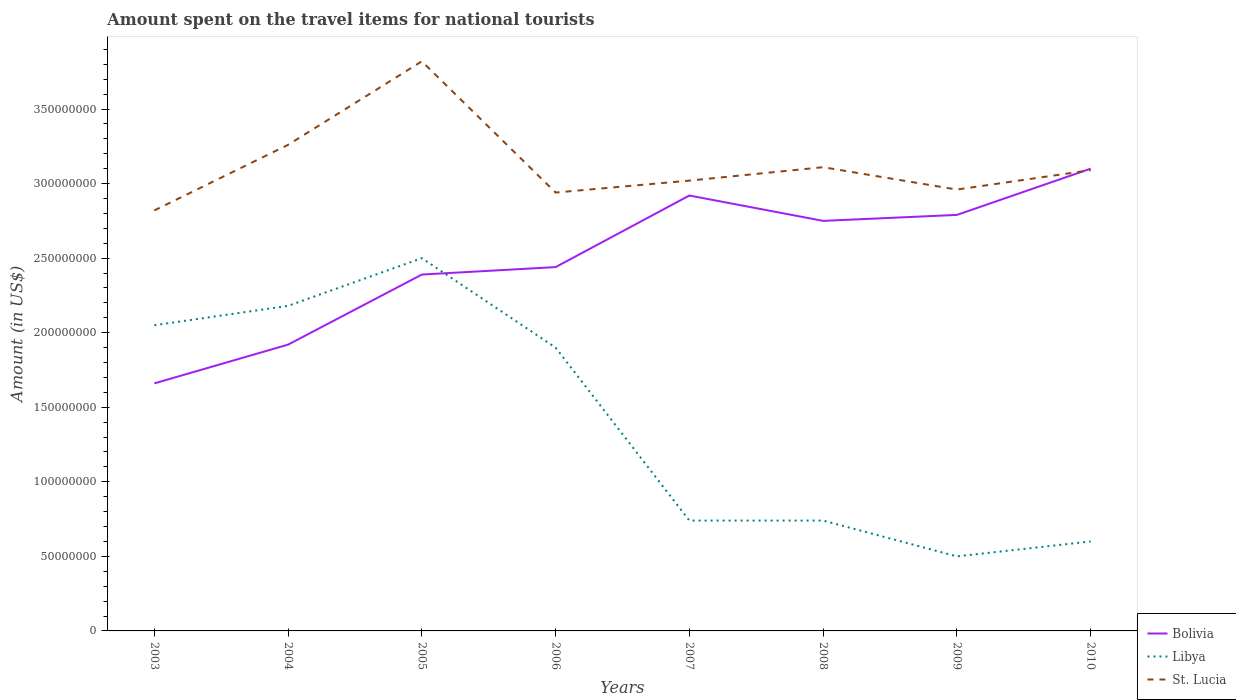Across all years, what is the maximum amount spent on the travel items for national tourists in St. Lucia?
Your response must be concise. 2.82e+08. In which year was the amount spent on the travel items for national tourists in Libya maximum?
Ensure brevity in your answer.  2009. What is the total amount spent on the travel items for national tourists in Bolivia in the graph?
Offer a terse response. -4.80e+07. What is the difference between the highest and the second highest amount spent on the travel items for national tourists in Bolivia?
Offer a very short reply. 1.44e+08. What is the difference between the highest and the lowest amount spent on the travel items for national tourists in Libya?
Ensure brevity in your answer.  4. Is the amount spent on the travel items for national tourists in St. Lucia strictly greater than the amount spent on the travel items for national tourists in Bolivia over the years?
Your response must be concise. No. Are the values on the major ticks of Y-axis written in scientific E-notation?
Your answer should be compact. No. What is the title of the graph?
Keep it short and to the point. Amount spent on the travel items for national tourists. What is the label or title of the X-axis?
Your answer should be very brief. Years. What is the Amount (in US$) of Bolivia in 2003?
Give a very brief answer. 1.66e+08. What is the Amount (in US$) in Libya in 2003?
Ensure brevity in your answer.  2.05e+08. What is the Amount (in US$) of St. Lucia in 2003?
Keep it short and to the point. 2.82e+08. What is the Amount (in US$) in Bolivia in 2004?
Your response must be concise. 1.92e+08. What is the Amount (in US$) in Libya in 2004?
Provide a short and direct response. 2.18e+08. What is the Amount (in US$) of St. Lucia in 2004?
Keep it short and to the point. 3.26e+08. What is the Amount (in US$) of Bolivia in 2005?
Your answer should be compact. 2.39e+08. What is the Amount (in US$) of Libya in 2005?
Your answer should be compact. 2.50e+08. What is the Amount (in US$) of St. Lucia in 2005?
Keep it short and to the point. 3.82e+08. What is the Amount (in US$) of Bolivia in 2006?
Your answer should be compact. 2.44e+08. What is the Amount (in US$) of Libya in 2006?
Offer a terse response. 1.90e+08. What is the Amount (in US$) of St. Lucia in 2006?
Your answer should be very brief. 2.94e+08. What is the Amount (in US$) in Bolivia in 2007?
Give a very brief answer. 2.92e+08. What is the Amount (in US$) of Libya in 2007?
Provide a succinct answer. 7.40e+07. What is the Amount (in US$) of St. Lucia in 2007?
Provide a succinct answer. 3.02e+08. What is the Amount (in US$) of Bolivia in 2008?
Offer a terse response. 2.75e+08. What is the Amount (in US$) in Libya in 2008?
Your response must be concise. 7.40e+07. What is the Amount (in US$) of St. Lucia in 2008?
Make the answer very short. 3.11e+08. What is the Amount (in US$) in Bolivia in 2009?
Give a very brief answer. 2.79e+08. What is the Amount (in US$) of Libya in 2009?
Your answer should be compact. 5.00e+07. What is the Amount (in US$) of St. Lucia in 2009?
Provide a succinct answer. 2.96e+08. What is the Amount (in US$) of Bolivia in 2010?
Provide a succinct answer. 3.10e+08. What is the Amount (in US$) in Libya in 2010?
Keep it short and to the point. 6.00e+07. What is the Amount (in US$) of St. Lucia in 2010?
Provide a short and direct response. 3.09e+08. Across all years, what is the maximum Amount (in US$) of Bolivia?
Provide a short and direct response. 3.10e+08. Across all years, what is the maximum Amount (in US$) in Libya?
Make the answer very short. 2.50e+08. Across all years, what is the maximum Amount (in US$) of St. Lucia?
Make the answer very short. 3.82e+08. Across all years, what is the minimum Amount (in US$) in Bolivia?
Make the answer very short. 1.66e+08. Across all years, what is the minimum Amount (in US$) in St. Lucia?
Offer a very short reply. 2.82e+08. What is the total Amount (in US$) of Bolivia in the graph?
Ensure brevity in your answer.  2.00e+09. What is the total Amount (in US$) of Libya in the graph?
Provide a succinct answer. 1.12e+09. What is the total Amount (in US$) in St. Lucia in the graph?
Give a very brief answer. 2.50e+09. What is the difference between the Amount (in US$) in Bolivia in 2003 and that in 2004?
Your response must be concise. -2.60e+07. What is the difference between the Amount (in US$) in Libya in 2003 and that in 2004?
Make the answer very short. -1.30e+07. What is the difference between the Amount (in US$) in St. Lucia in 2003 and that in 2004?
Offer a very short reply. -4.40e+07. What is the difference between the Amount (in US$) in Bolivia in 2003 and that in 2005?
Keep it short and to the point. -7.30e+07. What is the difference between the Amount (in US$) in Libya in 2003 and that in 2005?
Ensure brevity in your answer.  -4.50e+07. What is the difference between the Amount (in US$) of St. Lucia in 2003 and that in 2005?
Provide a short and direct response. -1.00e+08. What is the difference between the Amount (in US$) of Bolivia in 2003 and that in 2006?
Make the answer very short. -7.80e+07. What is the difference between the Amount (in US$) of Libya in 2003 and that in 2006?
Keep it short and to the point. 1.50e+07. What is the difference between the Amount (in US$) of St. Lucia in 2003 and that in 2006?
Give a very brief answer. -1.20e+07. What is the difference between the Amount (in US$) of Bolivia in 2003 and that in 2007?
Ensure brevity in your answer.  -1.26e+08. What is the difference between the Amount (in US$) in Libya in 2003 and that in 2007?
Provide a short and direct response. 1.31e+08. What is the difference between the Amount (in US$) of St. Lucia in 2003 and that in 2007?
Give a very brief answer. -2.00e+07. What is the difference between the Amount (in US$) in Bolivia in 2003 and that in 2008?
Provide a succinct answer. -1.09e+08. What is the difference between the Amount (in US$) in Libya in 2003 and that in 2008?
Ensure brevity in your answer.  1.31e+08. What is the difference between the Amount (in US$) of St. Lucia in 2003 and that in 2008?
Your answer should be compact. -2.90e+07. What is the difference between the Amount (in US$) of Bolivia in 2003 and that in 2009?
Your response must be concise. -1.13e+08. What is the difference between the Amount (in US$) of Libya in 2003 and that in 2009?
Offer a terse response. 1.55e+08. What is the difference between the Amount (in US$) of St. Lucia in 2003 and that in 2009?
Your answer should be very brief. -1.40e+07. What is the difference between the Amount (in US$) of Bolivia in 2003 and that in 2010?
Offer a terse response. -1.44e+08. What is the difference between the Amount (in US$) of Libya in 2003 and that in 2010?
Ensure brevity in your answer.  1.45e+08. What is the difference between the Amount (in US$) in St. Lucia in 2003 and that in 2010?
Your response must be concise. -2.70e+07. What is the difference between the Amount (in US$) in Bolivia in 2004 and that in 2005?
Provide a short and direct response. -4.70e+07. What is the difference between the Amount (in US$) of Libya in 2004 and that in 2005?
Your answer should be compact. -3.20e+07. What is the difference between the Amount (in US$) of St. Lucia in 2004 and that in 2005?
Your response must be concise. -5.60e+07. What is the difference between the Amount (in US$) of Bolivia in 2004 and that in 2006?
Your answer should be very brief. -5.20e+07. What is the difference between the Amount (in US$) of Libya in 2004 and that in 2006?
Your answer should be compact. 2.80e+07. What is the difference between the Amount (in US$) in St. Lucia in 2004 and that in 2006?
Keep it short and to the point. 3.20e+07. What is the difference between the Amount (in US$) of Bolivia in 2004 and that in 2007?
Make the answer very short. -1.00e+08. What is the difference between the Amount (in US$) in Libya in 2004 and that in 2007?
Ensure brevity in your answer.  1.44e+08. What is the difference between the Amount (in US$) in St. Lucia in 2004 and that in 2007?
Give a very brief answer. 2.40e+07. What is the difference between the Amount (in US$) of Bolivia in 2004 and that in 2008?
Offer a very short reply. -8.30e+07. What is the difference between the Amount (in US$) of Libya in 2004 and that in 2008?
Give a very brief answer. 1.44e+08. What is the difference between the Amount (in US$) of St. Lucia in 2004 and that in 2008?
Your answer should be very brief. 1.50e+07. What is the difference between the Amount (in US$) in Bolivia in 2004 and that in 2009?
Make the answer very short. -8.70e+07. What is the difference between the Amount (in US$) in Libya in 2004 and that in 2009?
Your answer should be very brief. 1.68e+08. What is the difference between the Amount (in US$) in St. Lucia in 2004 and that in 2009?
Provide a succinct answer. 3.00e+07. What is the difference between the Amount (in US$) in Bolivia in 2004 and that in 2010?
Give a very brief answer. -1.18e+08. What is the difference between the Amount (in US$) in Libya in 2004 and that in 2010?
Offer a very short reply. 1.58e+08. What is the difference between the Amount (in US$) in St. Lucia in 2004 and that in 2010?
Make the answer very short. 1.70e+07. What is the difference between the Amount (in US$) of Bolivia in 2005 and that in 2006?
Your answer should be compact. -5.00e+06. What is the difference between the Amount (in US$) of Libya in 2005 and that in 2006?
Make the answer very short. 6.00e+07. What is the difference between the Amount (in US$) in St. Lucia in 2005 and that in 2006?
Provide a succinct answer. 8.80e+07. What is the difference between the Amount (in US$) in Bolivia in 2005 and that in 2007?
Your response must be concise. -5.30e+07. What is the difference between the Amount (in US$) in Libya in 2005 and that in 2007?
Give a very brief answer. 1.76e+08. What is the difference between the Amount (in US$) in St. Lucia in 2005 and that in 2007?
Make the answer very short. 8.00e+07. What is the difference between the Amount (in US$) in Bolivia in 2005 and that in 2008?
Provide a succinct answer. -3.60e+07. What is the difference between the Amount (in US$) of Libya in 2005 and that in 2008?
Your answer should be very brief. 1.76e+08. What is the difference between the Amount (in US$) of St. Lucia in 2005 and that in 2008?
Provide a succinct answer. 7.10e+07. What is the difference between the Amount (in US$) of Bolivia in 2005 and that in 2009?
Give a very brief answer. -4.00e+07. What is the difference between the Amount (in US$) in Libya in 2005 and that in 2009?
Offer a very short reply. 2.00e+08. What is the difference between the Amount (in US$) of St. Lucia in 2005 and that in 2009?
Your response must be concise. 8.60e+07. What is the difference between the Amount (in US$) in Bolivia in 2005 and that in 2010?
Your answer should be very brief. -7.10e+07. What is the difference between the Amount (in US$) in Libya in 2005 and that in 2010?
Keep it short and to the point. 1.90e+08. What is the difference between the Amount (in US$) of St. Lucia in 2005 and that in 2010?
Provide a succinct answer. 7.30e+07. What is the difference between the Amount (in US$) in Bolivia in 2006 and that in 2007?
Your response must be concise. -4.80e+07. What is the difference between the Amount (in US$) of Libya in 2006 and that in 2007?
Make the answer very short. 1.16e+08. What is the difference between the Amount (in US$) of St. Lucia in 2006 and that in 2007?
Provide a short and direct response. -8.00e+06. What is the difference between the Amount (in US$) in Bolivia in 2006 and that in 2008?
Your response must be concise. -3.10e+07. What is the difference between the Amount (in US$) in Libya in 2006 and that in 2008?
Provide a short and direct response. 1.16e+08. What is the difference between the Amount (in US$) in St. Lucia in 2006 and that in 2008?
Offer a terse response. -1.70e+07. What is the difference between the Amount (in US$) of Bolivia in 2006 and that in 2009?
Offer a terse response. -3.50e+07. What is the difference between the Amount (in US$) of Libya in 2006 and that in 2009?
Ensure brevity in your answer.  1.40e+08. What is the difference between the Amount (in US$) of St. Lucia in 2006 and that in 2009?
Your response must be concise. -2.00e+06. What is the difference between the Amount (in US$) of Bolivia in 2006 and that in 2010?
Give a very brief answer. -6.60e+07. What is the difference between the Amount (in US$) of Libya in 2006 and that in 2010?
Provide a short and direct response. 1.30e+08. What is the difference between the Amount (in US$) of St. Lucia in 2006 and that in 2010?
Offer a terse response. -1.50e+07. What is the difference between the Amount (in US$) in Bolivia in 2007 and that in 2008?
Provide a succinct answer. 1.70e+07. What is the difference between the Amount (in US$) in Libya in 2007 and that in 2008?
Provide a succinct answer. 0. What is the difference between the Amount (in US$) in St. Lucia in 2007 and that in 2008?
Keep it short and to the point. -9.00e+06. What is the difference between the Amount (in US$) of Bolivia in 2007 and that in 2009?
Make the answer very short. 1.30e+07. What is the difference between the Amount (in US$) in Libya in 2007 and that in 2009?
Keep it short and to the point. 2.40e+07. What is the difference between the Amount (in US$) of Bolivia in 2007 and that in 2010?
Provide a short and direct response. -1.80e+07. What is the difference between the Amount (in US$) of Libya in 2007 and that in 2010?
Give a very brief answer. 1.40e+07. What is the difference between the Amount (in US$) of St. Lucia in 2007 and that in 2010?
Offer a terse response. -7.00e+06. What is the difference between the Amount (in US$) of Bolivia in 2008 and that in 2009?
Your response must be concise. -4.00e+06. What is the difference between the Amount (in US$) in Libya in 2008 and that in 2009?
Offer a very short reply. 2.40e+07. What is the difference between the Amount (in US$) in St. Lucia in 2008 and that in 2009?
Offer a very short reply. 1.50e+07. What is the difference between the Amount (in US$) of Bolivia in 2008 and that in 2010?
Offer a very short reply. -3.50e+07. What is the difference between the Amount (in US$) in Libya in 2008 and that in 2010?
Keep it short and to the point. 1.40e+07. What is the difference between the Amount (in US$) in St. Lucia in 2008 and that in 2010?
Your answer should be compact. 2.00e+06. What is the difference between the Amount (in US$) of Bolivia in 2009 and that in 2010?
Provide a short and direct response. -3.10e+07. What is the difference between the Amount (in US$) in Libya in 2009 and that in 2010?
Give a very brief answer. -1.00e+07. What is the difference between the Amount (in US$) of St. Lucia in 2009 and that in 2010?
Your answer should be compact. -1.30e+07. What is the difference between the Amount (in US$) in Bolivia in 2003 and the Amount (in US$) in Libya in 2004?
Provide a succinct answer. -5.20e+07. What is the difference between the Amount (in US$) of Bolivia in 2003 and the Amount (in US$) of St. Lucia in 2004?
Provide a short and direct response. -1.60e+08. What is the difference between the Amount (in US$) in Libya in 2003 and the Amount (in US$) in St. Lucia in 2004?
Your response must be concise. -1.21e+08. What is the difference between the Amount (in US$) in Bolivia in 2003 and the Amount (in US$) in Libya in 2005?
Keep it short and to the point. -8.40e+07. What is the difference between the Amount (in US$) in Bolivia in 2003 and the Amount (in US$) in St. Lucia in 2005?
Provide a succinct answer. -2.16e+08. What is the difference between the Amount (in US$) of Libya in 2003 and the Amount (in US$) of St. Lucia in 2005?
Your answer should be very brief. -1.77e+08. What is the difference between the Amount (in US$) in Bolivia in 2003 and the Amount (in US$) in Libya in 2006?
Offer a very short reply. -2.40e+07. What is the difference between the Amount (in US$) of Bolivia in 2003 and the Amount (in US$) of St. Lucia in 2006?
Offer a very short reply. -1.28e+08. What is the difference between the Amount (in US$) in Libya in 2003 and the Amount (in US$) in St. Lucia in 2006?
Your answer should be very brief. -8.90e+07. What is the difference between the Amount (in US$) of Bolivia in 2003 and the Amount (in US$) of Libya in 2007?
Provide a short and direct response. 9.20e+07. What is the difference between the Amount (in US$) in Bolivia in 2003 and the Amount (in US$) in St. Lucia in 2007?
Give a very brief answer. -1.36e+08. What is the difference between the Amount (in US$) in Libya in 2003 and the Amount (in US$) in St. Lucia in 2007?
Offer a terse response. -9.70e+07. What is the difference between the Amount (in US$) of Bolivia in 2003 and the Amount (in US$) of Libya in 2008?
Keep it short and to the point. 9.20e+07. What is the difference between the Amount (in US$) in Bolivia in 2003 and the Amount (in US$) in St. Lucia in 2008?
Provide a succinct answer. -1.45e+08. What is the difference between the Amount (in US$) of Libya in 2003 and the Amount (in US$) of St. Lucia in 2008?
Your answer should be compact. -1.06e+08. What is the difference between the Amount (in US$) of Bolivia in 2003 and the Amount (in US$) of Libya in 2009?
Your answer should be very brief. 1.16e+08. What is the difference between the Amount (in US$) in Bolivia in 2003 and the Amount (in US$) in St. Lucia in 2009?
Your response must be concise. -1.30e+08. What is the difference between the Amount (in US$) of Libya in 2003 and the Amount (in US$) of St. Lucia in 2009?
Give a very brief answer. -9.10e+07. What is the difference between the Amount (in US$) of Bolivia in 2003 and the Amount (in US$) of Libya in 2010?
Offer a terse response. 1.06e+08. What is the difference between the Amount (in US$) of Bolivia in 2003 and the Amount (in US$) of St. Lucia in 2010?
Provide a short and direct response. -1.43e+08. What is the difference between the Amount (in US$) of Libya in 2003 and the Amount (in US$) of St. Lucia in 2010?
Your answer should be compact. -1.04e+08. What is the difference between the Amount (in US$) in Bolivia in 2004 and the Amount (in US$) in Libya in 2005?
Make the answer very short. -5.80e+07. What is the difference between the Amount (in US$) in Bolivia in 2004 and the Amount (in US$) in St. Lucia in 2005?
Provide a short and direct response. -1.90e+08. What is the difference between the Amount (in US$) in Libya in 2004 and the Amount (in US$) in St. Lucia in 2005?
Provide a short and direct response. -1.64e+08. What is the difference between the Amount (in US$) in Bolivia in 2004 and the Amount (in US$) in St. Lucia in 2006?
Give a very brief answer. -1.02e+08. What is the difference between the Amount (in US$) of Libya in 2004 and the Amount (in US$) of St. Lucia in 2006?
Give a very brief answer. -7.60e+07. What is the difference between the Amount (in US$) of Bolivia in 2004 and the Amount (in US$) of Libya in 2007?
Keep it short and to the point. 1.18e+08. What is the difference between the Amount (in US$) of Bolivia in 2004 and the Amount (in US$) of St. Lucia in 2007?
Your answer should be compact. -1.10e+08. What is the difference between the Amount (in US$) of Libya in 2004 and the Amount (in US$) of St. Lucia in 2007?
Give a very brief answer. -8.40e+07. What is the difference between the Amount (in US$) in Bolivia in 2004 and the Amount (in US$) in Libya in 2008?
Give a very brief answer. 1.18e+08. What is the difference between the Amount (in US$) in Bolivia in 2004 and the Amount (in US$) in St. Lucia in 2008?
Your response must be concise. -1.19e+08. What is the difference between the Amount (in US$) of Libya in 2004 and the Amount (in US$) of St. Lucia in 2008?
Offer a terse response. -9.30e+07. What is the difference between the Amount (in US$) in Bolivia in 2004 and the Amount (in US$) in Libya in 2009?
Ensure brevity in your answer.  1.42e+08. What is the difference between the Amount (in US$) of Bolivia in 2004 and the Amount (in US$) of St. Lucia in 2009?
Your answer should be very brief. -1.04e+08. What is the difference between the Amount (in US$) of Libya in 2004 and the Amount (in US$) of St. Lucia in 2009?
Offer a very short reply. -7.80e+07. What is the difference between the Amount (in US$) in Bolivia in 2004 and the Amount (in US$) in Libya in 2010?
Offer a very short reply. 1.32e+08. What is the difference between the Amount (in US$) in Bolivia in 2004 and the Amount (in US$) in St. Lucia in 2010?
Ensure brevity in your answer.  -1.17e+08. What is the difference between the Amount (in US$) of Libya in 2004 and the Amount (in US$) of St. Lucia in 2010?
Your answer should be compact. -9.10e+07. What is the difference between the Amount (in US$) of Bolivia in 2005 and the Amount (in US$) of Libya in 2006?
Provide a short and direct response. 4.90e+07. What is the difference between the Amount (in US$) in Bolivia in 2005 and the Amount (in US$) in St. Lucia in 2006?
Your response must be concise. -5.50e+07. What is the difference between the Amount (in US$) in Libya in 2005 and the Amount (in US$) in St. Lucia in 2006?
Your answer should be very brief. -4.40e+07. What is the difference between the Amount (in US$) of Bolivia in 2005 and the Amount (in US$) of Libya in 2007?
Your answer should be very brief. 1.65e+08. What is the difference between the Amount (in US$) of Bolivia in 2005 and the Amount (in US$) of St. Lucia in 2007?
Provide a short and direct response. -6.30e+07. What is the difference between the Amount (in US$) of Libya in 2005 and the Amount (in US$) of St. Lucia in 2007?
Offer a very short reply. -5.20e+07. What is the difference between the Amount (in US$) of Bolivia in 2005 and the Amount (in US$) of Libya in 2008?
Your answer should be very brief. 1.65e+08. What is the difference between the Amount (in US$) of Bolivia in 2005 and the Amount (in US$) of St. Lucia in 2008?
Ensure brevity in your answer.  -7.20e+07. What is the difference between the Amount (in US$) in Libya in 2005 and the Amount (in US$) in St. Lucia in 2008?
Give a very brief answer. -6.10e+07. What is the difference between the Amount (in US$) of Bolivia in 2005 and the Amount (in US$) of Libya in 2009?
Your answer should be compact. 1.89e+08. What is the difference between the Amount (in US$) in Bolivia in 2005 and the Amount (in US$) in St. Lucia in 2009?
Your answer should be compact. -5.70e+07. What is the difference between the Amount (in US$) of Libya in 2005 and the Amount (in US$) of St. Lucia in 2009?
Give a very brief answer. -4.60e+07. What is the difference between the Amount (in US$) in Bolivia in 2005 and the Amount (in US$) in Libya in 2010?
Give a very brief answer. 1.79e+08. What is the difference between the Amount (in US$) in Bolivia in 2005 and the Amount (in US$) in St. Lucia in 2010?
Your answer should be very brief. -7.00e+07. What is the difference between the Amount (in US$) in Libya in 2005 and the Amount (in US$) in St. Lucia in 2010?
Ensure brevity in your answer.  -5.90e+07. What is the difference between the Amount (in US$) of Bolivia in 2006 and the Amount (in US$) of Libya in 2007?
Your answer should be very brief. 1.70e+08. What is the difference between the Amount (in US$) of Bolivia in 2006 and the Amount (in US$) of St. Lucia in 2007?
Your answer should be very brief. -5.80e+07. What is the difference between the Amount (in US$) of Libya in 2006 and the Amount (in US$) of St. Lucia in 2007?
Offer a very short reply. -1.12e+08. What is the difference between the Amount (in US$) of Bolivia in 2006 and the Amount (in US$) of Libya in 2008?
Make the answer very short. 1.70e+08. What is the difference between the Amount (in US$) of Bolivia in 2006 and the Amount (in US$) of St. Lucia in 2008?
Give a very brief answer. -6.70e+07. What is the difference between the Amount (in US$) in Libya in 2006 and the Amount (in US$) in St. Lucia in 2008?
Keep it short and to the point. -1.21e+08. What is the difference between the Amount (in US$) in Bolivia in 2006 and the Amount (in US$) in Libya in 2009?
Your response must be concise. 1.94e+08. What is the difference between the Amount (in US$) in Bolivia in 2006 and the Amount (in US$) in St. Lucia in 2009?
Offer a very short reply. -5.20e+07. What is the difference between the Amount (in US$) in Libya in 2006 and the Amount (in US$) in St. Lucia in 2009?
Your response must be concise. -1.06e+08. What is the difference between the Amount (in US$) of Bolivia in 2006 and the Amount (in US$) of Libya in 2010?
Your answer should be very brief. 1.84e+08. What is the difference between the Amount (in US$) in Bolivia in 2006 and the Amount (in US$) in St. Lucia in 2010?
Offer a very short reply. -6.50e+07. What is the difference between the Amount (in US$) in Libya in 2006 and the Amount (in US$) in St. Lucia in 2010?
Offer a very short reply. -1.19e+08. What is the difference between the Amount (in US$) of Bolivia in 2007 and the Amount (in US$) of Libya in 2008?
Your answer should be very brief. 2.18e+08. What is the difference between the Amount (in US$) in Bolivia in 2007 and the Amount (in US$) in St. Lucia in 2008?
Provide a short and direct response. -1.90e+07. What is the difference between the Amount (in US$) of Libya in 2007 and the Amount (in US$) of St. Lucia in 2008?
Keep it short and to the point. -2.37e+08. What is the difference between the Amount (in US$) in Bolivia in 2007 and the Amount (in US$) in Libya in 2009?
Make the answer very short. 2.42e+08. What is the difference between the Amount (in US$) of Bolivia in 2007 and the Amount (in US$) of St. Lucia in 2009?
Provide a short and direct response. -4.00e+06. What is the difference between the Amount (in US$) of Libya in 2007 and the Amount (in US$) of St. Lucia in 2009?
Offer a terse response. -2.22e+08. What is the difference between the Amount (in US$) of Bolivia in 2007 and the Amount (in US$) of Libya in 2010?
Your response must be concise. 2.32e+08. What is the difference between the Amount (in US$) in Bolivia in 2007 and the Amount (in US$) in St. Lucia in 2010?
Ensure brevity in your answer.  -1.70e+07. What is the difference between the Amount (in US$) in Libya in 2007 and the Amount (in US$) in St. Lucia in 2010?
Make the answer very short. -2.35e+08. What is the difference between the Amount (in US$) of Bolivia in 2008 and the Amount (in US$) of Libya in 2009?
Make the answer very short. 2.25e+08. What is the difference between the Amount (in US$) in Bolivia in 2008 and the Amount (in US$) in St. Lucia in 2009?
Offer a terse response. -2.10e+07. What is the difference between the Amount (in US$) in Libya in 2008 and the Amount (in US$) in St. Lucia in 2009?
Offer a very short reply. -2.22e+08. What is the difference between the Amount (in US$) in Bolivia in 2008 and the Amount (in US$) in Libya in 2010?
Make the answer very short. 2.15e+08. What is the difference between the Amount (in US$) of Bolivia in 2008 and the Amount (in US$) of St. Lucia in 2010?
Make the answer very short. -3.40e+07. What is the difference between the Amount (in US$) of Libya in 2008 and the Amount (in US$) of St. Lucia in 2010?
Offer a very short reply. -2.35e+08. What is the difference between the Amount (in US$) of Bolivia in 2009 and the Amount (in US$) of Libya in 2010?
Your response must be concise. 2.19e+08. What is the difference between the Amount (in US$) of Bolivia in 2009 and the Amount (in US$) of St. Lucia in 2010?
Keep it short and to the point. -3.00e+07. What is the difference between the Amount (in US$) in Libya in 2009 and the Amount (in US$) in St. Lucia in 2010?
Provide a succinct answer. -2.59e+08. What is the average Amount (in US$) of Bolivia per year?
Keep it short and to the point. 2.50e+08. What is the average Amount (in US$) in Libya per year?
Provide a short and direct response. 1.40e+08. What is the average Amount (in US$) in St. Lucia per year?
Provide a short and direct response. 3.13e+08. In the year 2003, what is the difference between the Amount (in US$) of Bolivia and Amount (in US$) of Libya?
Provide a succinct answer. -3.90e+07. In the year 2003, what is the difference between the Amount (in US$) of Bolivia and Amount (in US$) of St. Lucia?
Give a very brief answer. -1.16e+08. In the year 2003, what is the difference between the Amount (in US$) in Libya and Amount (in US$) in St. Lucia?
Keep it short and to the point. -7.70e+07. In the year 2004, what is the difference between the Amount (in US$) in Bolivia and Amount (in US$) in Libya?
Your answer should be very brief. -2.60e+07. In the year 2004, what is the difference between the Amount (in US$) of Bolivia and Amount (in US$) of St. Lucia?
Your response must be concise. -1.34e+08. In the year 2004, what is the difference between the Amount (in US$) of Libya and Amount (in US$) of St. Lucia?
Your answer should be compact. -1.08e+08. In the year 2005, what is the difference between the Amount (in US$) of Bolivia and Amount (in US$) of Libya?
Your response must be concise. -1.10e+07. In the year 2005, what is the difference between the Amount (in US$) in Bolivia and Amount (in US$) in St. Lucia?
Make the answer very short. -1.43e+08. In the year 2005, what is the difference between the Amount (in US$) in Libya and Amount (in US$) in St. Lucia?
Provide a succinct answer. -1.32e+08. In the year 2006, what is the difference between the Amount (in US$) in Bolivia and Amount (in US$) in Libya?
Make the answer very short. 5.40e+07. In the year 2006, what is the difference between the Amount (in US$) in Bolivia and Amount (in US$) in St. Lucia?
Offer a terse response. -5.00e+07. In the year 2006, what is the difference between the Amount (in US$) of Libya and Amount (in US$) of St. Lucia?
Offer a terse response. -1.04e+08. In the year 2007, what is the difference between the Amount (in US$) in Bolivia and Amount (in US$) in Libya?
Offer a terse response. 2.18e+08. In the year 2007, what is the difference between the Amount (in US$) in Bolivia and Amount (in US$) in St. Lucia?
Offer a very short reply. -1.00e+07. In the year 2007, what is the difference between the Amount (in US$) of Libya and Amount (in US$) of St. Lucia?
Offer a very short reply. -2.28e+08. In the year 2008, what is the difference between the Amount (in US$) of Bolivia and Amount (in US$) of Libya?
Offer a very short reply. 2.01e+08. In the year 2008, what is the difference between the Amount (in US$) of Bolivia and Amount (in US$) of St. Lucia?
Give a very brief answer. -3.60e+07. In the year 2008, what is the difference between the Amount (in US$) in Libya and Amount (in US$) in St. Lucia?
Provide a short and direct response. -2.37e+08. In the year 2009, what is the difference between the Amount (in US$) of Bolivia and Amount (in US$) of Libya?
Your answer should be compact. 2.29e+08. In the year 2009, what is the difference between the Amount (in US$) in Bolivia and Amount (in US$) in St. Lucia?
Offer a terse response. -1.70e+07. In the year 2009, what is the difference between the Amount (in US$) of Libya and Amount (in US$) of St. Lucia?
Give a very brief answer. -2.46e+08. In the year 2010, what is the difference between the Amount (in US$) in Bolivia and Amount (in US$) in Libya?
Make the answer very short. 2.50e+08. In the year 2010, what is the difference between the Amount (in US$) in Bolivia and Amount (in US$) in St. Lucia?
Offer a terse response. 1.00e+06. In the year 2010, what is the difference between the Amount (in US$) of Libya and Amount (in US$) of St. Lucia?
Provide a succinct answer. -2.49e+08. What is the ratio of the Amount (in US$) of Bolivia in 2003 to that in 2004?
Provide a short and direct response. 0.86. What is the ratio of the Amount (in US$) of Libya in 2003 to that in 2004?
Keep it short and to the point. 0.94. What is the ratio of the Amount (in US$) of St. Lucia in 2003 to that in 2004?
Give a very brief answer. 0.86. What is the ratio of the Amount (in US$) of Bolivia in 2003 to that in 2005?
Offer a very short reply. 0.69. What is the ratio of the Amount (in US$) of Libya in 2003 to that in 2005?
Ensure brevity in your answer.  0.82. What is the ratio of the Amount (in US$) of St. Lucia in 2003 to that in 2005?
Provide a short and direct response. 0.74. What is the ratio of the Amount (in US$) of Bolivia in 2003 to that in 2006?
Your response must be concise. 0.68. What is the ratio of the Amount (in US$) in Libya in 2003 to that in 2006?
Give a very brief answer. 1.08. What is the ratio of the Amount (in US$) of St. Lucia in 2003 to that in 2006?
Offer a very short reply. 0.96. What is the ratio of the Amount (in US$) of Bolivia in 2003 to that in 2007?
Your answer should be compact. 0.57. What is the ratio of the Amount (in US$) of Libya in 2003 to that in 2007?
Your answer should be compact. 2.77. What is the ratio of the Amount (in US$) of St. Lucia in 2003 to that in 2007?
Keep it short and to the point. 0.93. What is the ratio of the Amount (in US$) of Bolivia in 2003 to that in 2008?
Ensure brevity in your answer.  0.6. What is the ratio of the Amount (in US$) in Libya in 2003 to that in 2008?
Make the answer very short. 2.77. What is the ratio of the Amount (in US$) of St. Lucia in 2003 to that in 2008?
Offer a terse response. 0.91. What is the ratio of the Amount (in US$) in Bolivia in 2003 to that in 2009?
Provide a succinct answer. 0.59. What is the ratio of the Amount (in US$) of Libya in 2003 to that in 2009?
Your answer should be compact. 4.1. What is the ratio of the Amount (in US$) of St. Lucia in 2003 to that in 2009?
Your response must be concise. 0.95. What is the ratio of the Amount (in US$) of Bolivia in 2003 to that in 2010?
Provide a short and direct response. 0.54. What is the ratio of the Amount (in US$) of Libya in 2003 to that in 2010?
Give a very brief answer. 3.42. What is the ratio of the Amount (in US$) in St. Lucia in 2003 to that in 2010?
Your response must be concise. 0.91. What is the ratio of the Amount (in US$) in Bolivia in 2004 to that in 2005?
Provide a succinct answer. 0.8. What is the ratio of the Amount (in US$) in Libya in 2004 to that in 2005?
Keep it short and to the point. 0.87. What is the ratio of the Amount (in US$) of St. Lucia in 2004 to that in 2005?
Provide a succinct answer. 0.85. What is the ratio of the Amount (in US$) of Bolivia in 2004 to that in 2006?
Give a very brief answer. 0.79. What is the ratio of the Amount (in US$) in Libya in 2004 to that in 2006?
Your answer should be compact. 1.15. What is the ratio of the Amount (in US$) of St. Lucia in 2004 to that in 2006?
Offer a very short reply. 1.11. What is the ratio of the Amount (in US$) of Bolivia in 2004 to that in 2007?
Provide a succinct answer. 0.66. What is the ratio of the Amount (in US$) in Libya in 2004 to that in 2007?
Keep it short and to the point. 2.95. What is the ratio of the Amount (in US$) of St. Lucia in 2004 to that in 2007?
Your response must be concise. 1.08. What is the ratio of the Amount (in US$) of Bolivia in 2004 to that in 2008?
Your answer should be compact. 0.7. What is the ratio of the Amount (in US$) of Libya in 2004 to that in 2008?
Provide a short and direct response. 2.95. What is the ratio of the Amount (in US$) in St. Lucia in 2004 to that in 2008?
Provide a succinct answer. 1.05. What is the ratio of the Amount (in US$) of Bolivia in 2004 to that in 2009?
Your answer should be very brief. 0.69. What is the ratio of the Amount (in US$) in Libya in 2004 to that in 2009?
Offer a very short reply. 4.36. What is the ratio of the Amount (in US$) of St. Lucia in 2004 to that in 2009?
Offer a terse response. 1.1. What is the ratio of the Amount (in US$) in Bolivia in 2004 to that in 2010?
Your answer should be compact. 0.62. What is the ratio of the Amount (in US$) in Libya in 2004 to that in 2010?
Your answer should be compact. 3.63. What is the ratio of the Amount (in US$) of St. Lucia in 2004 to that in 2010?
Offer a very short reply. 1.05. What is the ratio of the Amount (in US$) of Bolivia in 2005 to that in 2006?
Offer a very short reply. 0.98. What is the ratio of the Amount (in US$) of Libya in 2005 to that in 2006?
Keep it short and to the point. 1.32. What is the ratio of the Amount (in US$) of St. Lucia in 2005 to that in 2006?
Ensure brevity in your answer.  1.3. What is the ratio of the Amount (in US$) of Bolivia in 2005 to that in 2007?
Your answer should be compact. 0.82. What is the ratio of the Amount (in US$) in Libya in 2005 to that in 2007?
Ensure brevity in your answer.  3.38. What is the ratio of the Amount (in US$) in St. Lucia in 2005 to that in 2007?
Offer a very short reply. 1.26. What is the ratio of the Amount (in US$) in Bolivia in 2005 to that in 2008?
Provide a short and direct response. 0.87. What is the ratio of the Amount (in US$) in Libya in 2005 to that in 2008?
Offer a terse response. 3.38. What is the ratio of the Amount (in US$) in St. Lucia in 2005 to that in 2008?
Your response must be concise. 1.23. What is the ratio of the Amount (in US$) in Bolivia in 2005 to that in 2009?
Make the answer very short. 0.86. What is the ratio of the Amount (in US$) in St. Lucia in 2005 to that in 2009?
Give a very brief answer. 1.29. What is the ratio of the Amount (in US$) of Bolivia in 2005 to that in 2010?
Provide a short and direct response. 0.77. What is the ratio of the Amount (in US$) of Libya in 2005 to that in 2010?
Keep it short and to the point. 4.17. What is the ratio of the Amount (in US$) in St. Lucia in 2005 to that in 2010?
Provide a short and direct response. 1.24. What is the ratio of the Amount (in US$) in Bolivia in 2006 to that in 2007?
Your answer should be very brief. 0.84. What is the ratio of the Amount (in US$) in Libya in 2006 to that in 2007?
Provide a short and direct response. 2.57. What is the ratio of the Amount (in US$) of St. Lucia in 2006 to that in 2007?
Your answer should be very brief. 0.97. What is the ratio of the Amount (in US$) in Bolivia in 2006 to that in 2008?
Offer a terse response. 0.89. What is the ratio of the Amount (in US$) of Libya in 2006 to that in 2008?
Offer a very short reply. 2.57. What is the ratio of the Amount (in US$) in St. Lucia in 2006 to that in 2008?
Give a very brief answer. 0.95. What is the ratio of the Amount (in US$) in Bolivia in 2006 to that in 2009?
Your response must be concise. 0.87. What is the ratio of the Amount (in US$) in St. Lucia in 2006 to that in 2009?
Give a very brief answer. 0.99. What is the ratio of the Amount (in US$) of Bolivia in 2006 to that in 2010?
Provide a short and direct response. 0.79. What is the ratio of the Amount (in US$) of Libya in 2006 to that in 2010?
Ensure brevity in your answer.  3.17. What is the ratio of the Amount (in US$) of St. Lucia in 2006 to that in 2010?
Offer a terse response. 0.95. What is the ratio of the Amount (in US$) of Bolivia in 2007 to that in 2008?
Ensure brevity in your answer.  1.06. What is the ratio of the Amount (in US$) in St. Lucia in 2007 to that in 2008?
Keep it short and to the point. 0.97. What is the ratio of the Amount (in US$) in Bolivia in 2007 to that in 2009?
Give a very brief answer. 1.05. What is the ratio of the Amount (in US$) in Libya in 2007 to that in 2009?
Ensure brevity in your answer.  1.48. What is the ratio of the Amount (in US$) of St. Lucia in 2007 to that in 2009?
Provide a short and direct response. 1.02. What is the ratio of the Amount (in US$) in Bolivia in 2007 to that in 2010?
Provide a short and direct response. 0.94. What is the ratio of the Amount (in US$) in Libya in 2007 to that in 2010?
Your answer should be very brief. 1.23. What is the ratio of the Amount (in US$) in St. Lucia in 2007 to that in 2010?
Give a very brief answer. 0.98. What is the ratio of the Amount (in US$) of Bolivia in 2008 to that in 2009?
Make the answer very short. 0.99. What is the ratio of the Amount (in US$) of Libya in 2008 to that in 2009?
Make the answer very short. 1.48. What is the ratio of the Amount (in US$) of St. Lucia in 2008 to that in 2009?
Your answer should be very brief. 1.05. What is the ratio of the Amount (in US$) of Bolivia in 2008 to that in 2010?
Your answer should be compact. 0.89. What is the ratio of the Amount (in US$) in Libya in 2008 to that in 2010?
Offer a very short reply. 1.23. What is the ratio of the Amount (in US$) in Bolivia in 2009 to that in 2010?
Make the answer very short. 0.9. What is the ratio of the Amount (in US$) of St. Lucia in 2009 to that in 2010?
Give a very brief answer. 0.96. What is the difference between the highest and the second highest Amount (in US$) in Bolivia?
Provide a short and direct response. 1.80e+07. What is the difference between the highest and the second highest Amount (in US$) of Libya?
Keep it short and to the point. 3.20e+07. What is the difference between the highest and the second highest Amount (in US$) of St. Lucia?
Provide a short and direct response. 5.60e+07. What is the difference between the highest and the lowest Amount (in US$) in Bolivia?
Your response must be concise. 1.44e+08. 